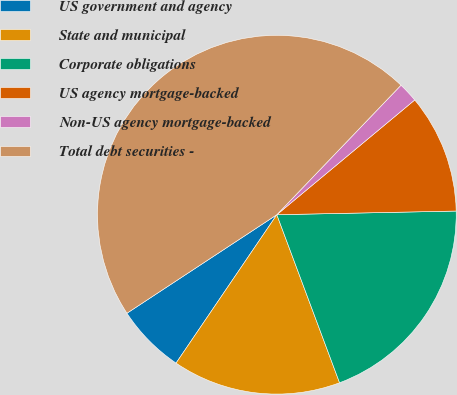Convert chart. <chart><loc_0><loc_0><loc_500><loc_500><pie_chart><fcel>US government and agency<fcel>State and municipal<fcel>Corporate obligations<fcel>US agency mortgage-backed<fcel>Non-US agency mortgage-backed<fcel>Total debt securities -<nl><fcel>6.25%<fcel>15.18%<fcel>19.64%<fcel>10.72%<fcel>1.79%<fcel>46.42%<nl></chart> 